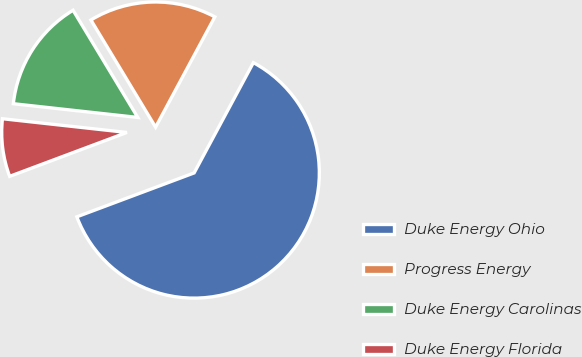<chart> <loc_0><loc_0><loc_500><loc_500><pie_chart><fcel>Duke Energy Ohio<fcel>Progress Energy<fcel>Duke Energy Carolinas<fcel>Duke Energy Florida<nl><fcel>61.46%<fcel>16.49%<fcel>14.61%<fcel>7.45%<nl></chart> 